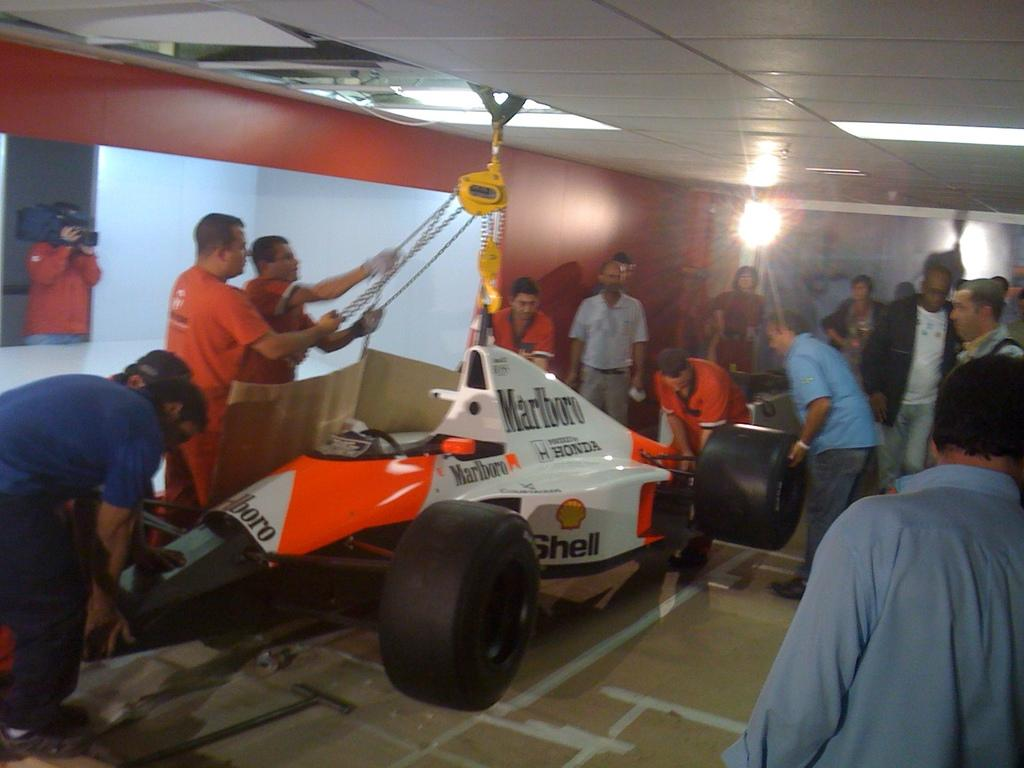What is happening in the image involving people? There are people standing in the image, and some of them are working with an F1 race car. Where is the F1 race car located in the image? The F1 race car is in the middle of the image. What type of farm animals can be seen in the image? There are no farm animals present in the image; it features people working with an F1 race car. What is the purpose of the chain in the image? There is no chain present in the image. 